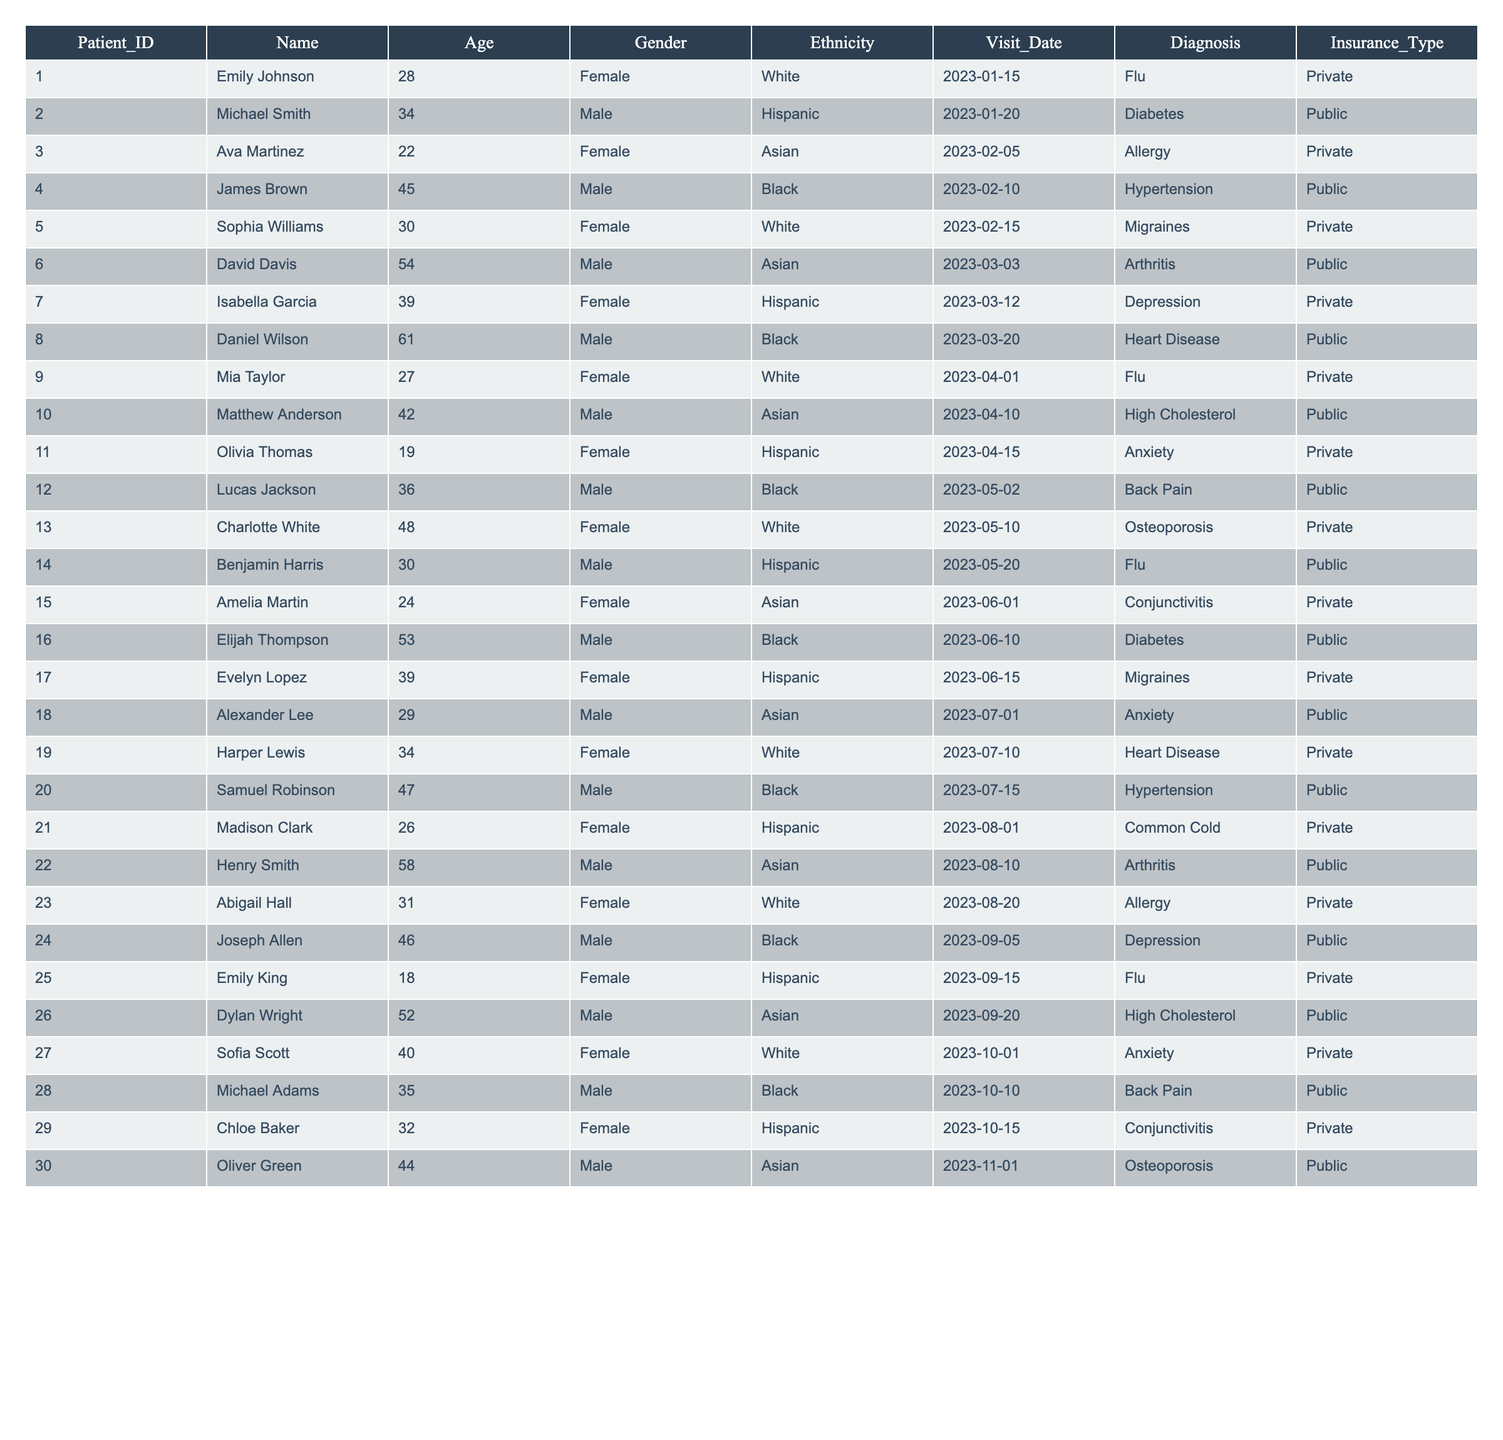What is the most common diagnosis among the patients? By examining the 'Diagnosis' column, we can count the occurrences of each diagnosis listed. The diagnosis 'Flu' appears 5 times, which is higher than any other diagnosis.
Answer: Flu How many female patients visited the clinic? To determine the number of female patients, we count the entries under the 'Gender' column where the value is 'Female'. There are 15 female patients in total.
Answer: 15 What is the age of the oldest patient? We can look at the 'Age' column and identify the maximum value. The highest age in the list is 61, which corresponds to the patient Daniel Wilson.
Answer: 61 How many patients were diagnosed with Depression? We can count the number of times 'Depression' appears in the 'Diagnosis' column. It appears 3 times among the patients listed.
Answer: 3 Is there a patient with the diagnosis of Osteoporosis under the age of 50? By filtering the table to find patients diagnosed with Osteoporosis, we see that 'Charlotte White' is 48 years old, which is under 50. Therefore, the statement is true.
Answer: Yes What percentage of patients have Public insurance? First, we count the total number of patients, which is 30. Next, we count how many patients have 'Public' insurance, which is 14. The percentage is (14/30) * 100 = 46.67%.
Answer: 46.67% What is the average age of Female patients? We first filter the ages of female patients, which gives us the ages: 28, 22, 30, 39, 19, 24, 39, 26, 31, and 40. Adding these together gives us  28 + 22 + 30 + 39 + 19 + 24 + 39 + 26 + 31 + 40 =  328. There are 10 female patients, so the average age is 328/10 = 32.8.
Answer: 32.8 Which ethnicity has the highest representation among patients diagnosed with Diabetes? We look at the 'Diagnosis' column and find that 'Diabetes' is mentioned once, with Michael Smith being Hispanic. Therefore, the ethnicity with the highest representation among diabetes patients is Hispanic.
Answer: Hispanic How many patients over 40 have been diagnosed with heart disease? We filter the diagnoses for 'Heart Disease' and check the ages. The patients with this diagnosis, Daniel Wilson (61) and Harper Lewis (34), show that only one, Daniel, is over 40.
Answer: 1 What is the total number of male patients compared to female patients? By counting, we find there are 15 males and 15 females in the table. Therefore, the number of male patients equals the number of female patients.
Answer: Equal 